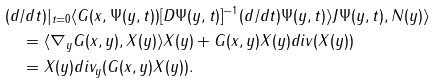<formula> <loc_0><loc_0><loc_500><loc_500>& ( d / d t ) | _ { t = 0 } \langle G ( x , \Psi ( y , t ) ) [ D \Psi ( y , t ) ] ^ { - 1 } ( d / d t ) \Psi ( y , t ) \rangle J \Psi ( y , t ) , N ( y ) \rangle \\ & \quad = \langle \nabla _ { y } G ( x , y ) , X ( y ) \rangle X ( y ) + G ( x , y ) X ( y ) d i v ( X ( y ) ) \\ & \quad = X ( y ) d i v _ { y } ( G ( x , y ) X ( y ) ) .</formula> 